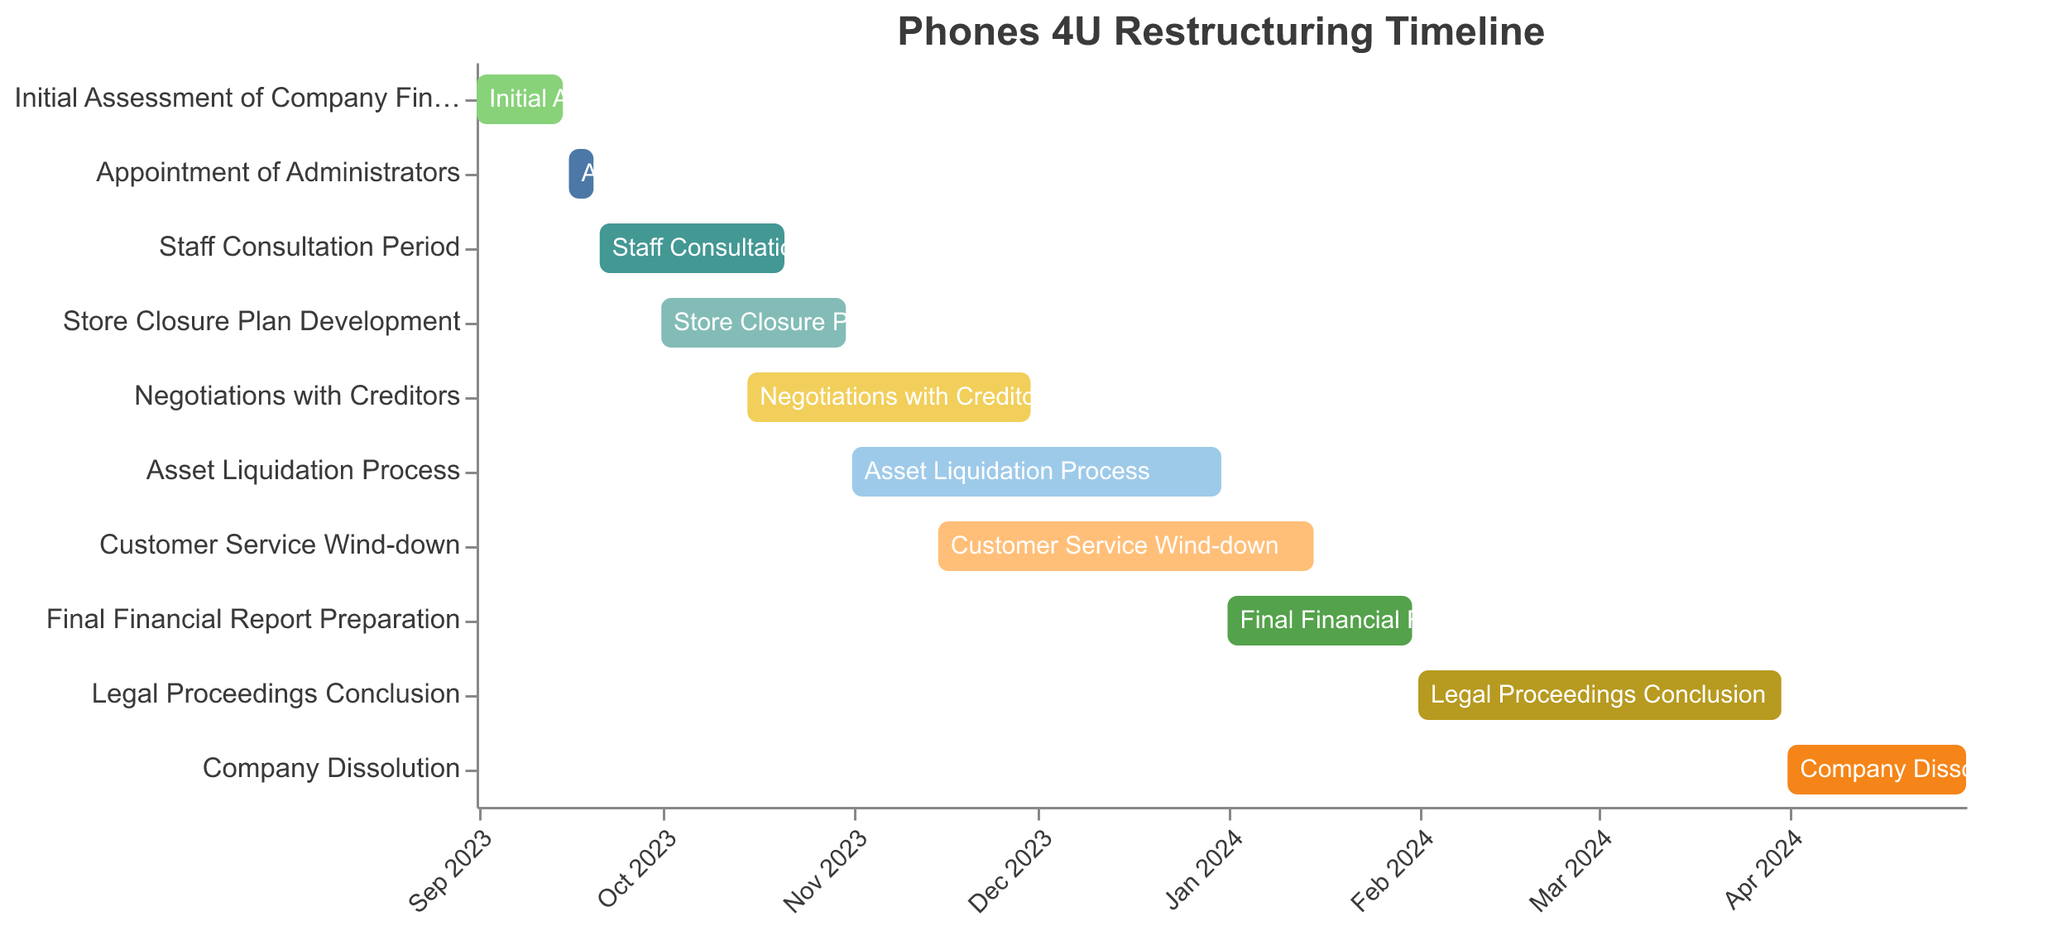What is the title of the Gantt chart? The title of the Gantt chart is located at the top of the figure. It is typically centered and provides an overview of the chart's content.
Answer: Phones 4U Restructuring Timeline What is the start date for the Staff Consultation Period? The start date is displayed on the horizontal axis and corresponds to the bar representing the Staff Consultation Period. The date is on the left side of the bar.
Answer: September 21, 2023 Which task has the shortest duration? The duration of each task is represented by the length of the bars. Comparing their lengths visually allows identifying the shortest one.
Answer: Appointment of Administrators How many tasks are scheduled to start in November 2023? Tasks that start in November 2023 are identified by looking at the start dates along the horizontal axis and counting those that fall within November 2023.
Answer: Three When does the legal proceedings conclusion begin? To find the start date, locate the bar labeled "Legal Proceedings Conclusion" and check the date on the left side of the bar.
Answer: February 1, 2024 Which task overlaps with both the Asset Liquidation Process and Customer Service Wind-down? Overlapping tasks can be identified by looking for bars that span the same time intervals as both the Asset Liquidation Process and Customer Service Wind-down.
Answer: Negotiations with Creditors What is the duration of the Final Financial Report Preparation task? The duration is calculated by finding the difference between the end date and the start date of the task.
Answer: 31 days Compare the duration of the Store Closure Plan Development with the Negotiations with Creditors. Which one is longer? Compare the lengths of the bars representing these tasks. The one with the longer bar duration is longer.
Answer: Negotiations with Creditors What is the last task in the restructuring process? The last task is the one with the latest end date, which is at the far right of the chart.
Answer: Company Dissolution Is there any task that spans exactly two months? To check this, identify tasks where the difference between start and end dates is approximately two months.
Answer: Yes, Legal Proceedings Conclusion 